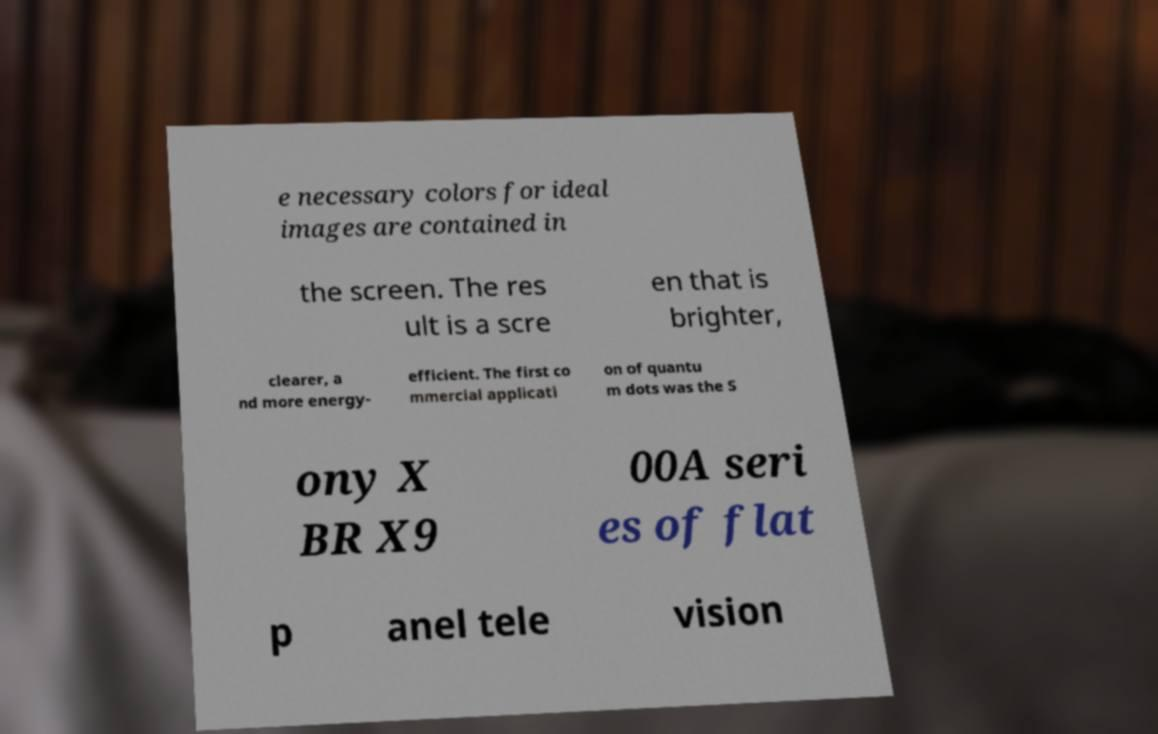Can you read and provide the text displayed in the image?This photo seems to have some interesting text. Can you extract and type it out for me? e necessary colors for ideal images are contained in the screen. The res ult is a scre en that is brighter, clearer, a nd more energy- efficient. The first co mmercial applicati on of quantu m dots was the S ony X BR X9 00A seri es of flat p anel tele vision 